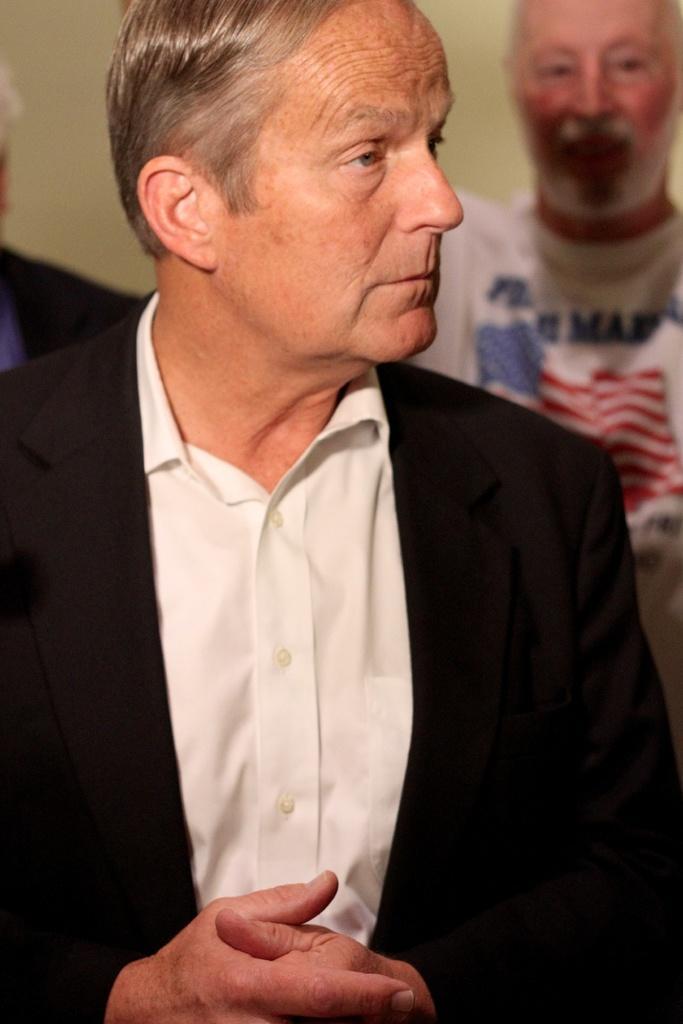In one or two sentences, can you explain what this image depicts? In this picture, we can see a few people, and we can see a person in the front is highlighted and w e can see the blurred background. 